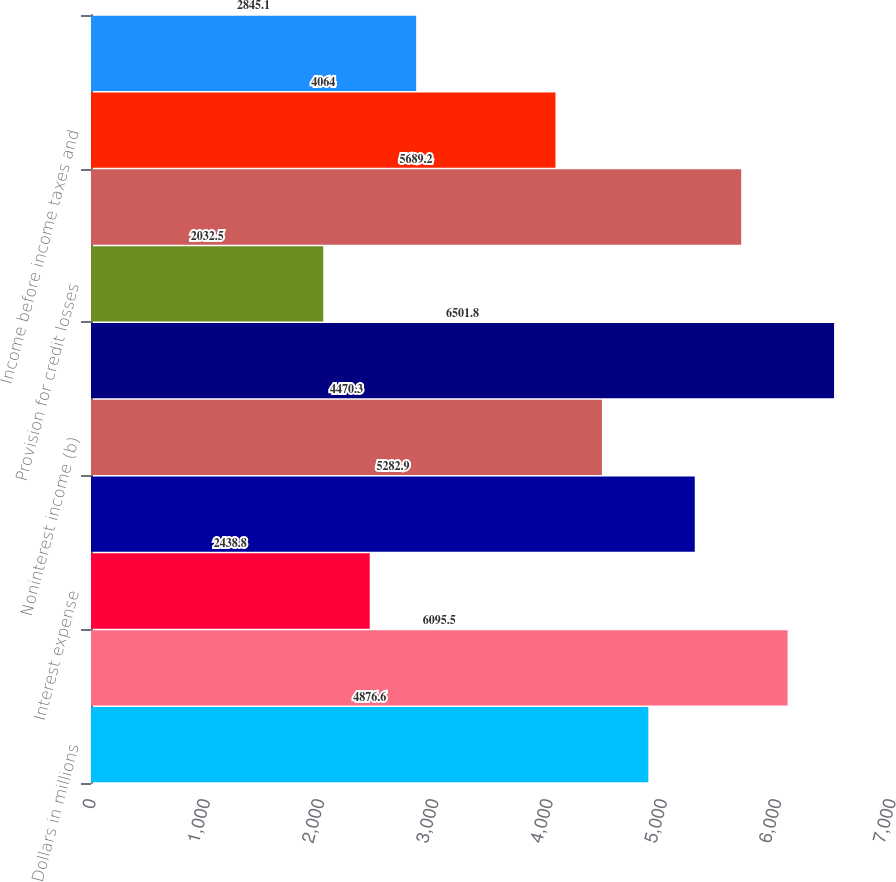Convert chart to OTSL. <chart><loc_0><loc_0><loc_500><loc_500><bar_chart><fcel>Dollars in millions<fcel>Interest income<fcel>Interest expense<fcel>Net interest income<fcel>Noninterest income (b)<fcel>Total revenue<fcel>Provision for credit losses<fcel>Noninterest expense<fcel>Income before income taxes and<fcel>Income taxes<nl><fcel>4876.6<fcel>6095.5<fcel>2438.8<fcel>5282.9<fcel>4470.3<fcel>6501.8<fcel>2032.5<fcel>5689.2<fcel>4064<fcel>2845.1<nl></chart> 